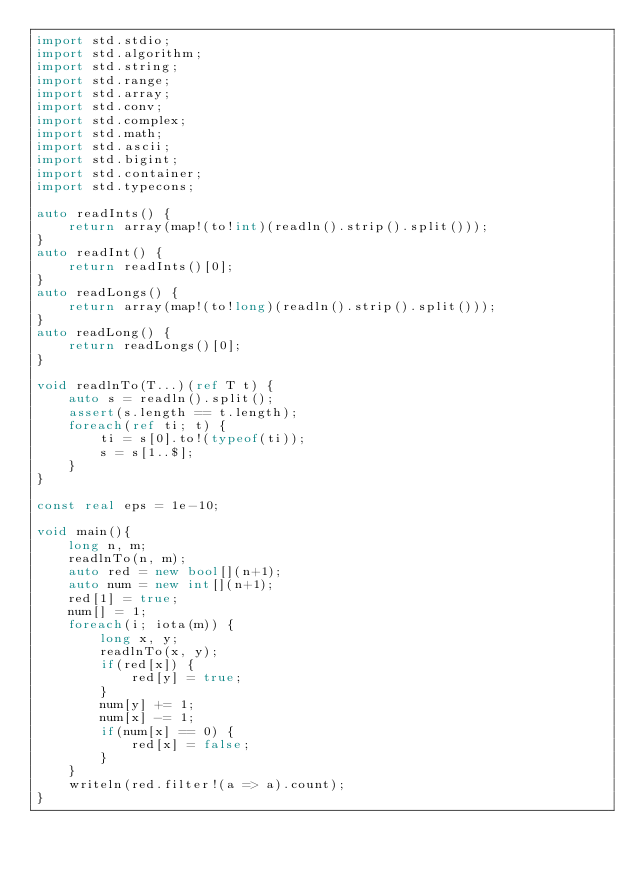Convert code to text. <code><loc_0><loc_0><loc_500><loc_500><_D_>import std.stdio;
import std.algorithm;
import std.string;
import std.range;
import std.array;
import std.conv;
import std.complex;
import std.math;
import std.ascii;
import std.bigint;
import std.container;
import std.typecons;

auto readInts() {
	return array(map!(to!int)(readln().strip().split()));
}
auto readInt() {
	return readInts()[0];
}
auto readLongs() {
	return array(map!(to!long)(readln().strip().split()));
}
auto readLong() {
	return readLongs()[0];
}

void readlnTo(T...)(ref T t) {
    auto s = readln().split();
    assert(s.length == t.length);
    foreach(ref ti; t) {
        ti = s[0].to!(typeof(ti));
        s = s[1..$];
    }
}

const real eps = 1e-10;

void main(){
    long n, m;
    readlnTo(n, m);
    auto red = new bool[](n+1);
    auto num = new int[](n+1);
    red[1] = true;
    num[] = 1;
    foreach(i; iota(m)) {
        long x, y;
        readlnTo(x, y);
        if(red[x]) {
            red[y] = true;
        }
        num[y] += 1;
        num[x] -= 1;
        if(num[x] == 0) {
            red[x] = false;
        }
    }
    writeln(red.filter!(a => a).count);
}

</code> 